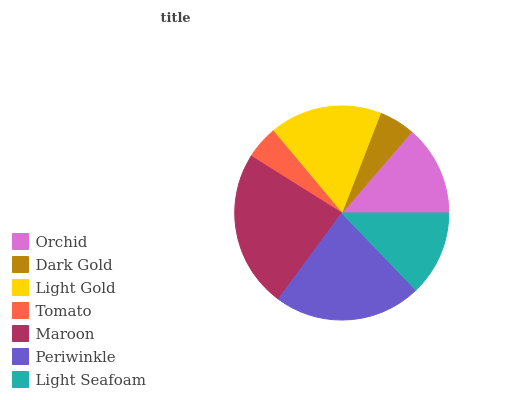Is Tomato the minimum?
Answer yes or no. Yes. Is Maroon the maximum?
Answer yes or no. Yes. Is Dark Gold the minimum?
Answer yes or no. No. Is Dark Gold the maximum?
Answer yes or no. No. Is Orchid greater than Dark Gold?
Answer yes or no. Yes. Is Dark Gold less than Orchid?
Answer yes or no. Yes. Is Dark Gold greater than Orchid?
Answer yes or no. No. Is Orchid less than Dark Gold?
Answer yes or no. No. Is Orchid the high median?
Answer yes or no. Yes. Is Orchid the low median?
Answer yes or no. Yes. Is Dark Gold the high median?
Answer yes or no. No. Is Tomato the low median?
Answer yes or no. No. 